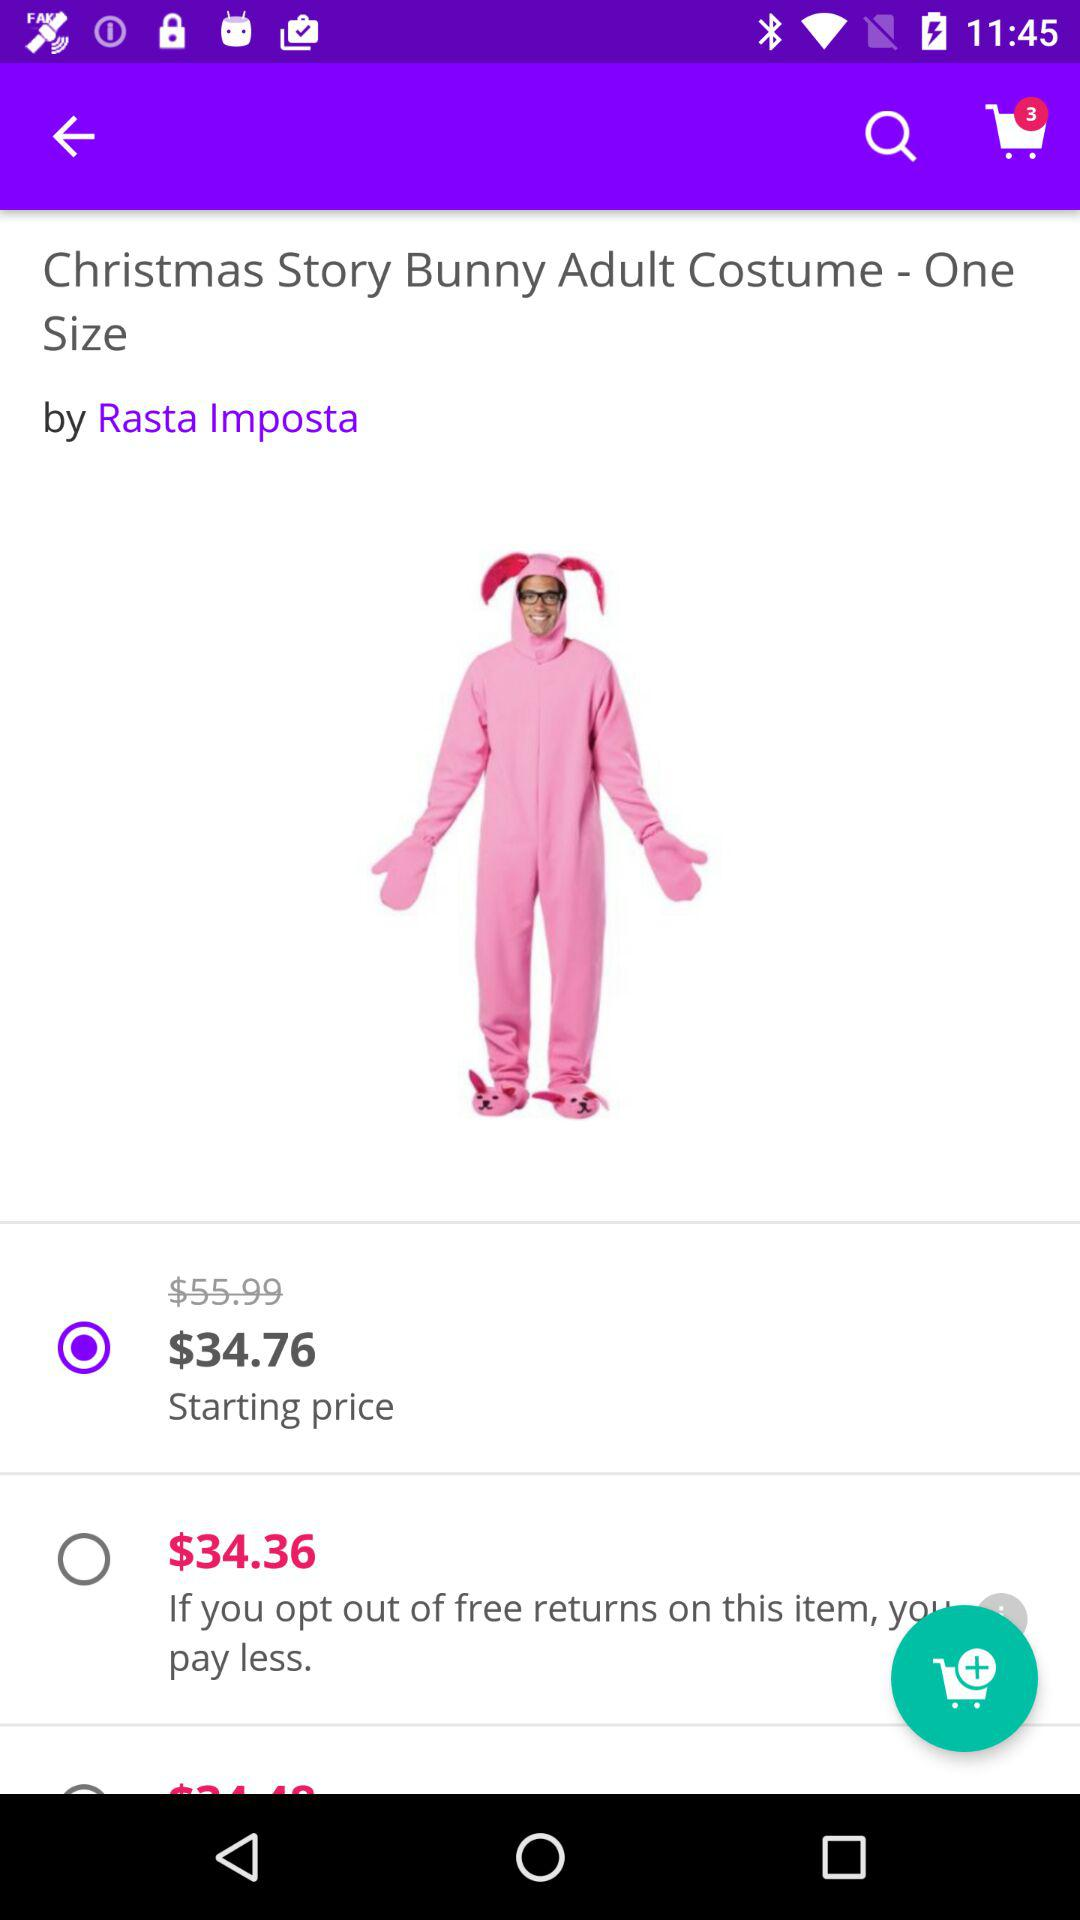What is the number of items in the cart? The number of items in the cart is 3. 